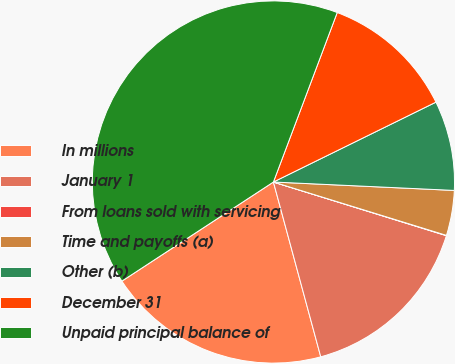Convert chart to OTSL. <chart><loc_0><loc_0><loc_500><loc_500><pie_chart><fcel>In millions<fcel>January 1<fcel>From loans sold with servicing<fcel>Time and payoffs (a)<fcel>Other (b)<fcel>December 31<fcel>Unpaid principal balance of<nl><fcel>19.99%<fcel>16.0%<fcel>0.03%<fcel>4.02%<fcel>8.01%<fcel>12.0%<fcel>39.95%<nl></chart> 